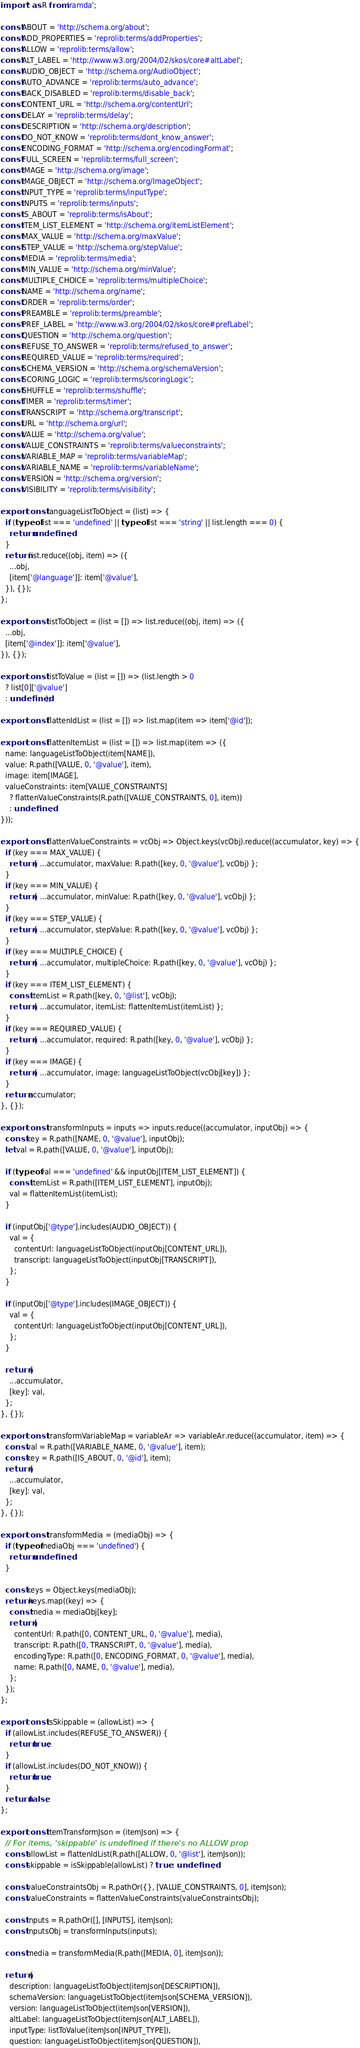<code> <loc_0><loc_0><loc_500><loc_500><_JavaScript_>import * as R from 'ramda';

const ABOUT = 'http://schema.org/about';
const ADD_PROPERTIES = 'reprolib:terms/addProperties';
const ALLOW = 'reprolib:terms/allow';
const ALT_LABEL = 'http://www.w3.org/2004/02/skos/core#altLabel';
const AUDIO_OBJECT = 'http://schema.org/AudioObject';
const AUTO_ADVANCE = 'reprolib:terms/auto_advance';
const BACK_DISABLED = 'reprolib:terms/disable_back';
const CONTENT_URL = 'http://schema.org/contentUrl';
const DELAY = 'reprolib:terms/delay';
const DESCRIPTION = 'http://schema.org/description';
const DO_NOT_KNOW = 'reprolib:terms/dont_know_answer';
const ENCODING_FORMAT = 'http://schema.org/encodingFormat';
const FULL_SCREEN = 'reprolib:terms/full_screen';
const IMAGE = 'http://schema.org/image';
const IMAGE_OBJECT = 'http://schema.org/ImageObject';
const INPUT_TYPE = 'reprolib:terms/inputType';
const INPUTS = 'reprolib:terms/inputs';
const IS_ABOUT = 'reprolib:terms/isAbout';
const ITEM_LIST_ELEMENT = 'http://schema.org/itemListElement';
const MAX_VALUE = 'http://schema.org/maxValue';
const STEP_VALUE = 'http://schema.org/stepValue';
const MEDIA = 'reprolib:terms/media';
const MIN_VALUE = 'http://schema.org/minValue';
const MULTIPLE_CHOICE = 'reprolib:terms/multipleChoice';
const NAME = 'http://schema.org/name';
const ORDER = 'reprolib:terms/order';
const PREAMBLE = 'reprolib:terms/preamble';
const PREF_LABEL = 'http://www.w3.org/2004/02/skos/core#prefLabel';
const QUESTION = 'http://schema.org/question';
const REFUSE_TO_ANSWER = 'reprolib:terms/refused_to_answer';
const REQUIRED_VALUE = 'reprolib:terms/required';
const SCHEMA_VERSION = 'http://schema.org/schemaVersion';
const SCORING_LOGIC = 'reprolib:terms/scoringLogic';
const SHUFFLE = 'reprolib:terms/shuffle';
const TIMER = 'reprolib:terms/timer';
const TRANSCRIPT = 'http://schema.org/transcript';
const URL = 'http://schema.org/url';
const VALUE = 'http://schema.org/value';
const VALUE_CONSTRAINTS = 'reprolib:terms/valueconstraints';
const VARIABLE_MAP = 'reprolib:terms/variableMap';
const VARIABLE_NAME = 'reprolib:terms/variableName';
const VERSION = 'http://schema.org/version';
const VISIBILITY = 'reprolib:terms/visibility';

export const languageListToObject = (list) => {
  if (typeof list === 'undefined' || typeof list === 'string' || list.length === 0) {
    return undefined;
  }
  return list.reduce((obj, item) => ({
    ...obj,
    [item['@language']]: item['@value'],
  }), {});
};

export const listToObject = (list = []) => list.reduce((obj, item) => ({
  ...obj,
  [item['@index']]: item['@value'],
}), {});

export const listToValue = (list = []) => (list.length > 0
  ? list[0]['@value']
  : undefined);

export const flattenIdList = (list = []) => list.map(item => item['@id']);

export const flattenItemList = (list = []) => list.map(item => ({
  name: languageListToObject(item[NAME]),
  value: R.path([VALUE, 0, '@value'], item),
  image: item[IMAGE],
  valueConstraints: item[VALUE_CONSTRAINTS]
    ? flattenValueConstraints(R.path([VALUE_CONSTRAINTS, 0], item))
    : undefined,
}));

export const flattenValueConstraints = vcObj => Object.keys(vcObj).reduce((accumulator, key) => {
  if (key === MAX_VALUE) {
    return { ...accumulator, maxValue: R.path([key, 0, '@value'], vcObj) };
  }
  if (key === MIN_VALUE) {
    return { ...accumulator, minValue: R.path([key, 0, '@value'], vcObj) };
  }
  if (key === STEP_VALUE) {
    return { ...accumulator, stepValue: R.path([key, 0, '@value'], vcObj) };
  }
  if (key === MULTIPLE_CHOICE) {
    return { ...accumulator, multipleChoice: R.path([key, 0, '@value'], vcObj) };
  }
  if (key === ITEM_LIST_ELEMENT) {
    const itemList = R.path([key, 0, '@list'], vcObj);
    return { ...accumulator, itemList: flattenItemList(itemList) };
  }
  if (key === REQUIRED_VALUE) {
    return { ...accumulator, required: R.path([key, 0, '@value'], vcObj) };
  }
  if (key === IMAGE) {
    return { ...accumulator, image: languageListToObject(vcObj[key]) };
  }
  return accumulator;
}, {});

export const transformInputs = inputs => inputs.reduce((accumulator, inputObj) => {
  const key = R.path([NAME, 0, '@value'], inputObj);
  let val = R.path([VALUE, 0, '@value'], inputObj);

  if (typeof val === 'undefined' && inputObj[ITEM_LIST_ELEMENT]) {
    const itemList = R.path([ITEM_LIST_ELEMENT], inputObj);
    val = flattenItemList(itemList);
  }

  if (inputObj['@type'].includes(AUDIO_OBJECT)) {
    val = {
      contentUrl: languageListToObject(inputObj[CONTENT_URL]),
      transcript: languageListToObject(inputObj[TRANSCRIPT]),
    };
  }

  if (inputObj['@type'].includes(IMAGE_OBJECT)) {
    val = {
      contentUrl: languageListToObject(inputObj[CONTENT_URL]),
    };
  }

  return {
    ...accumulator,
    [key]: val,
  };
}, {});

export const transformVariableMap = variableAr => variableAr.reduce((accumulator, item) => {
  const val = R.path([VARIABLE_NAME, 0, '@value'], item);
  const key = R.path([IS_ABOUT, 0, '@id'], item);
  return {
    ...accumulator,
    [key]: val,
  };
}, {});

export const transformMedia = (mediaObj) => {
  if (typeof mediaObj === 'undefined') {
    return undefined;
  }

  const keys = Object.keys(mediaObj);
  return keys.map((key) => {
    const media = mediaObj[key];
    return {
      contentUrl: R.path([0, CONTENT_URL, 0, '@value'], media),
      transcript: R.path([0, TRANSCRIPT, 0, '@value'], media),
      encodingType: R.path([0, ENCODING_FORMAT, 0, '@value'], media),
      name: R.path([0, NAME, 0, '@value'], media),
    };
  });
};

export const isSkippable = (allowList) => {
  if (allowList.includes(REFUSE_TO_ANSWER)) {
    return true;
  }
  if (allowList.includes(DO_NOT_KNOW)) {
    return true;
  }
  return false;
};

export const itemTransformJson = (itemJson) => {
  // For items, 'skippable' is undefined if there's no ALLOW prop
  const allowList = flattenIdList(R.path([ALLOW, 0, '@list'], itemJson));
  const skippable = isSkippable(allowList) ? true : undefined;

  const valueConstraintsObj = R.pathOr({}, [VALUE_CONSTRAINTS, 0], itemJson);
  const valueConstraints = flattenValueConstraints(valueConstraintsObj);

  const inputs = R.pathOr([], [INPUTS], itemJson);
  const inputsObj = transformInputs(inputs);

  const media = transformMedia(R.path([MEDIA, 0], itemJson));

  return {
    description: languageListToObject(itemJson[DESCRIPTION]),
    schemaVersion: languageListToObject(itemJson[SCHEMA_VERSION]),
    version: languageListToObject(itemJson[VERSION]),
    altLabel: languageListToObject(itemJson[ALT_LABEL]),
    inputType: listToValue(itemJson[INPUT_TYPE]),
    question: languageListToObject(itemJson[QUESTION]),</code> 